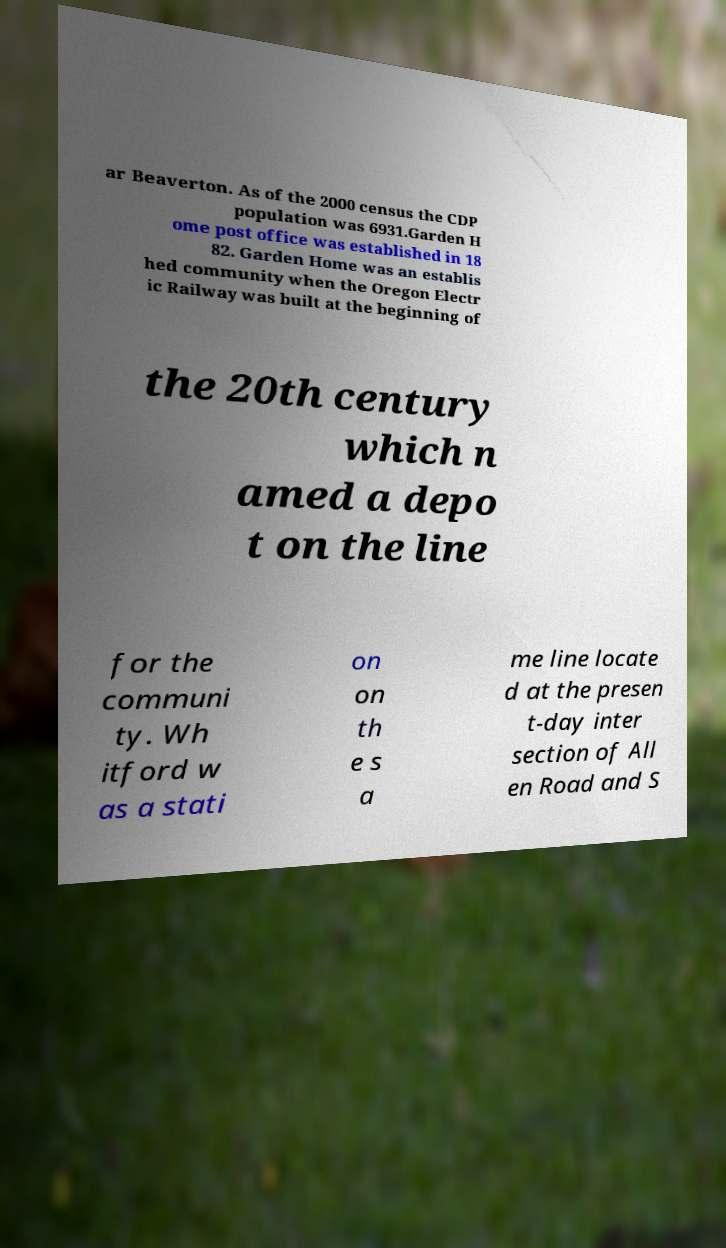There's text embedded in this image that I need extracted. Can you transcribe it verbatim? ar Beaverton. As of the 2000 census the CDP population was 6931.Garden H ome post office was established in 18 82. Garden Home was an establis hed community when the Oregon Electr ic Railway was built at the beginning of the 20th century which n amed a depo t on the line for the communi ty. Wh itford w as a stati on on th e s a me line locate d at the presen t-day inter section of All en Road and S 